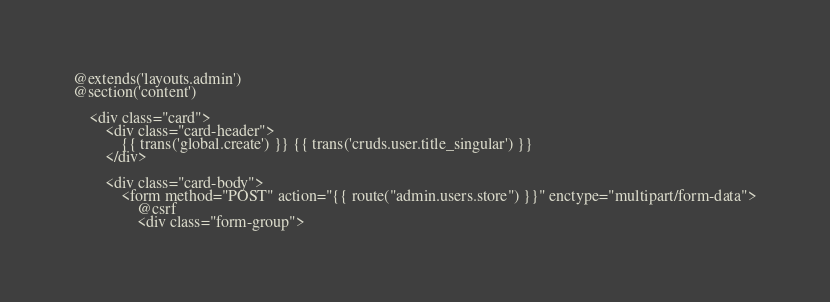Convert code to text. <code><loc_0><loc_0><loc_500><loc_500><_PHP_>@extends('layouts.admin')
@section('content')

    <div class="card">
        <div class="card-header">
            {{ trans('global.create') }} {{ trans('cruds.user.title_singular') }}
        </div>

        <div class="card-body">
            <form method="POST" action="{{ route("admin.users.store") }}" enctype="multipart/form-data">
                @csrf
                <div class="form-group"></code> 